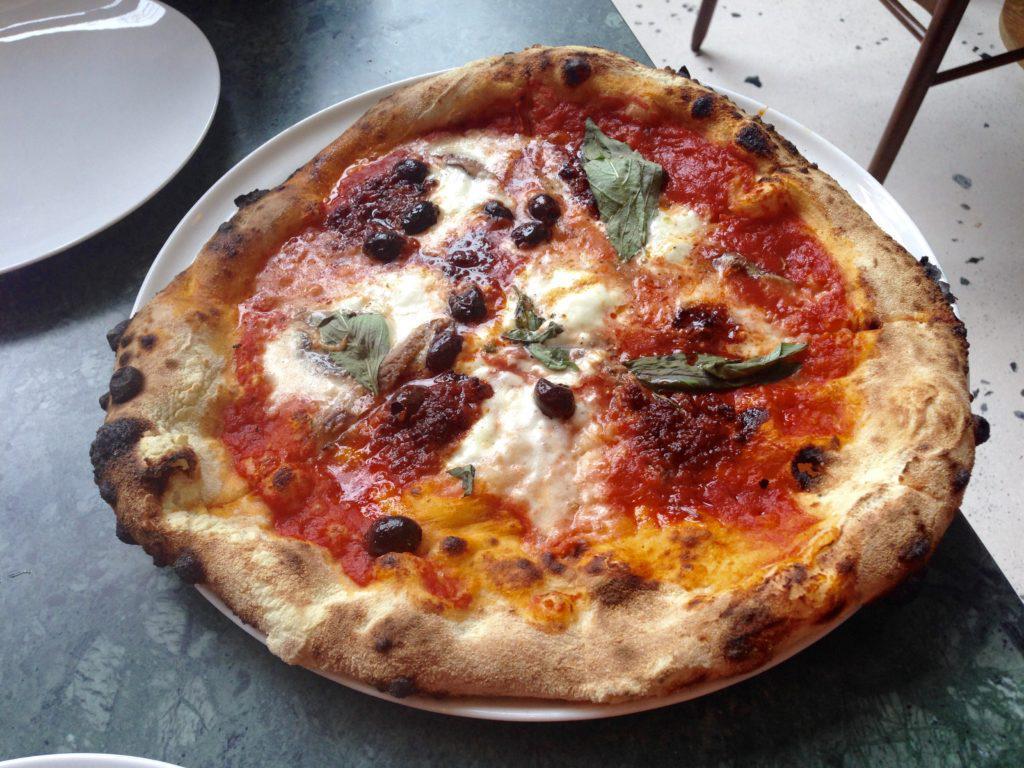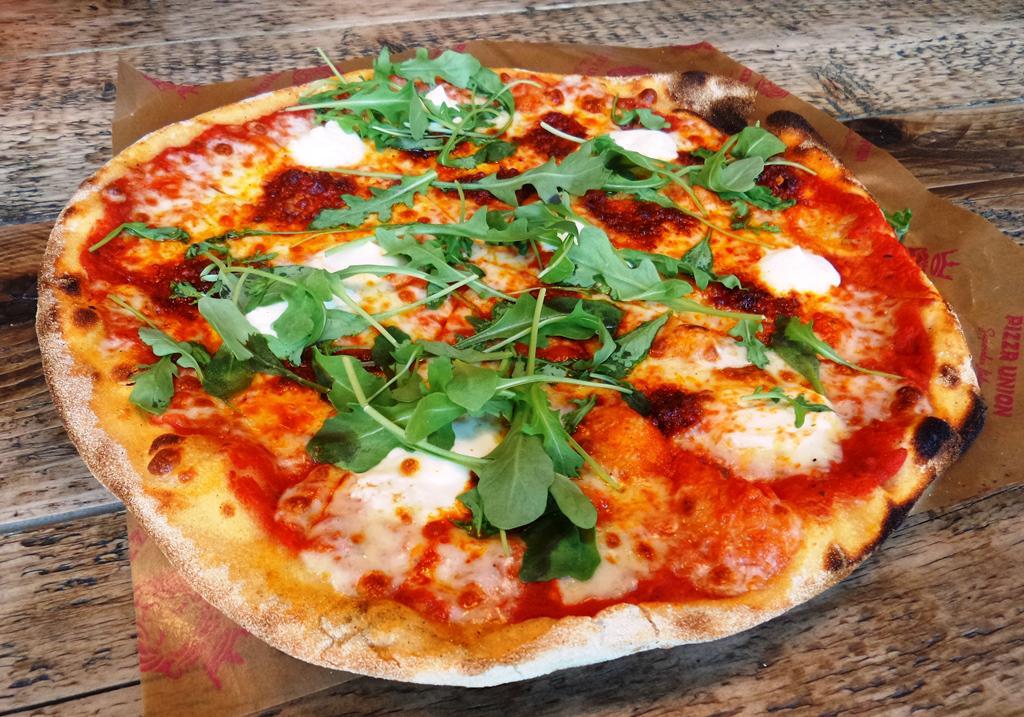The first image is the image on the left, the second image is the image on the right. Examine the images to the left and right. Is the description "A piece of pizza is missing." accurate? Answer yes or no. No. The first image is the image on the left, the second image is the image on the right. For the images displayed, is the sentence "There are two pizza and none of them are in a cardboard box." factually correct? Answer yes or no. Yes. 